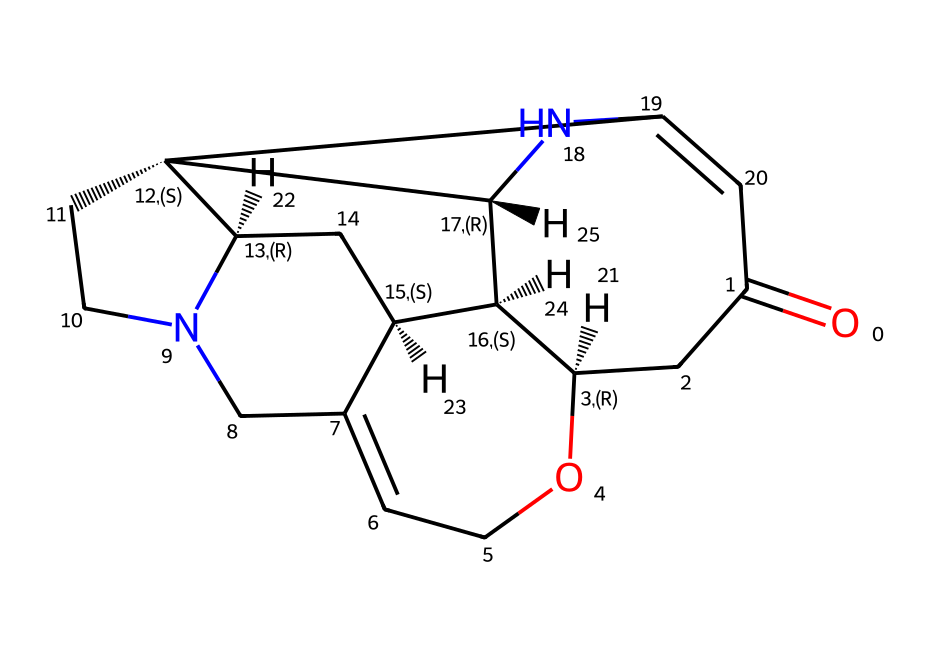What is the molecular formula of strychnine? To determine the molecular formula, we need to count the respective carbon (C), hydrogen (H), nitrogen (N), and oxygen (O) atoms present in the chemical structure. In this case, you would find 21 carbon atoms, 24 hydrogen atoms, 2 nitrogen atoms, and 1 oxygen atom. Therefore, the molecular formula is C21H24N2O.
Answer: C21H24N2O How many rings are present in the structure of strychnine? By examining the chemical structure, we can identify the number of cyclic parts. Strychnine contains three interconnected rings, which can be visually discerned from the SMILES representation and structural layout.
Answer: 3 Which element gives strychnine its toxicity? The presence of nitrogen atoms in strychnine greatly contributes to its toxicity. Nitrogen in alkaloids is often linked to neurological effects, and in the case of strychnine, it is specifically related to its action on the nervous system.
Answer: nitrogen What type of nitrogen is present in strychnine? To classify the nitrogen in strychnine, one must identify how the nitrogen atoms are incorporated into the structure. In strychnine, they are primary and secondary amines, which can be deduced from their positions and bonding.
Answer: amine How many double bonds are present in the structure? Count the double bonds directly from the chemical structure, particularly looking between carbon atoms and any attached heteroatoms. In the case of strychnine, there are several double bonds connecting various carbon components in the rings and side chains. Specifically, there are 4 double bonds.
Answer: 4 What functional groups are present in strychnine? By breaking down the structure and identifying specific atom arrangements, we recognize that strychnine contains an amine functional group due to its nitrogen atoms and a carbonyl group (C=O) as part of its structure.
Answer: amine, carbonyl 